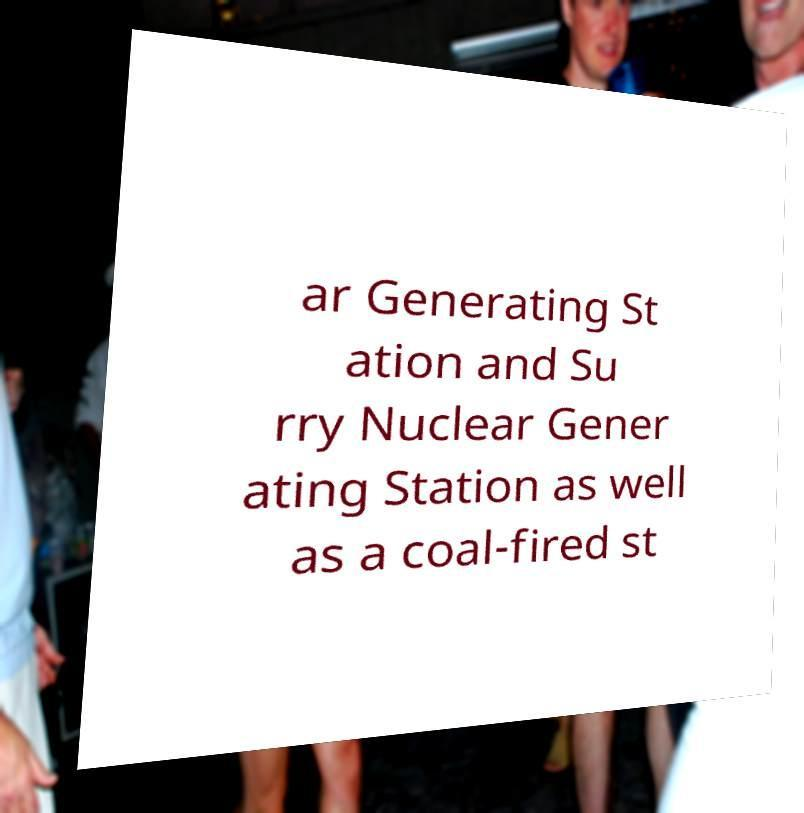I need the written content from this picture converted into text. Can you do that? ar Generating St ation and Su rry Nuclear Gener ating Station as well as a coal-fired st 